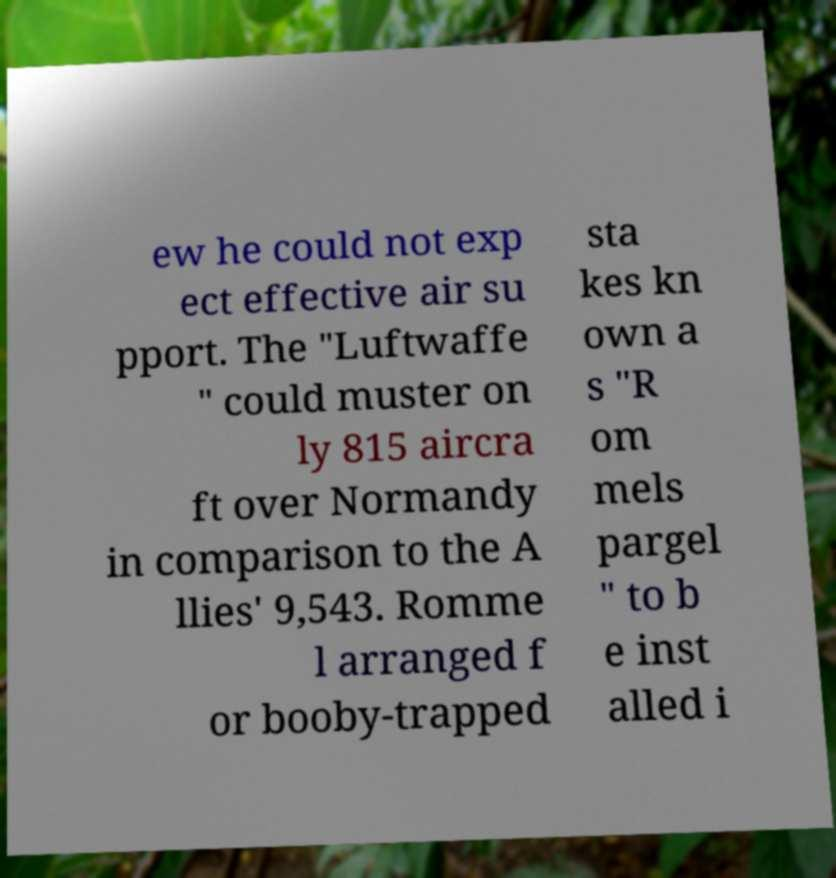For documentation purposes, I need the text within this image transcribed. Could you provide that? ew he could not exp ect effective air su pport. The "Luftwaffe " could muster on ly 815 aircra ft over Normandy in comparison to the A llies' 9,543. Romme l arranged f or booby-trapped sta kes kn own a s "R om mels pargel " to b e inst alled i 